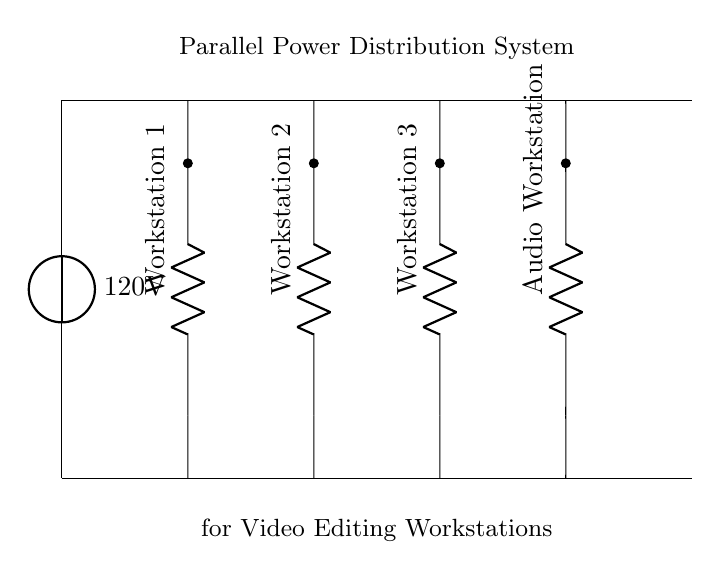What is the voltage of this circuit? The voltage source is labeled as 120 volts, which indicates the potential difference supplied to the entire circuit.
Answer: 120 volts How many workstations are connected in parallel? The diagram shows four resistors labeled as Workstation 1, Workstation 2, Workstation 3, and Audio Workstation, indicating four parallel connections.
Answer: Four What type of circuit configuration is shown? The circuit diagram distinctly shows multiple paths for current to travel to each workstation, signifying a parallel configuration.
Answer: Parallel What is the main source of power in this system? The circuit features a voltage source at the top labeled as 120 volts, which is the source of power for the entire system.
Answer: 120 volts If Workstation 1 draws 2 amps, what is the likely total current from the power source? In a parallel circuit, the total current is the sum of the currents through each parallel branch. Since only one branch’s current is provided (2 amps), the total cannot be determined unless the others are known. Thus, the answer is indeterminate.
Answer: Indeterminate What happens if one workstation fails? In a parallel configuration, if one workstation fails (like disconnecting a resistor), the current still flows to the other workstations since they have separate paths. Therefore, others remain operational.
Answer: Others remain operational 